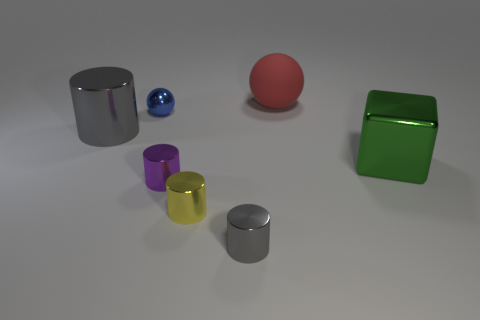Imagine if these objects had personality traits, how would you describe them? In this whimsical realm, the green cube might be the confident leader, its bright color and bold shape exuding strength. The red sphere could be the free spirit, rolling wherever its heart desires. The glossy yellow and purple cylinders are the cheerful optimists of the group, shining brightly and standing tall. And the two gray cylinders? They're the wise observers, their shiny metal surfaces reflecting the world as they see it. 